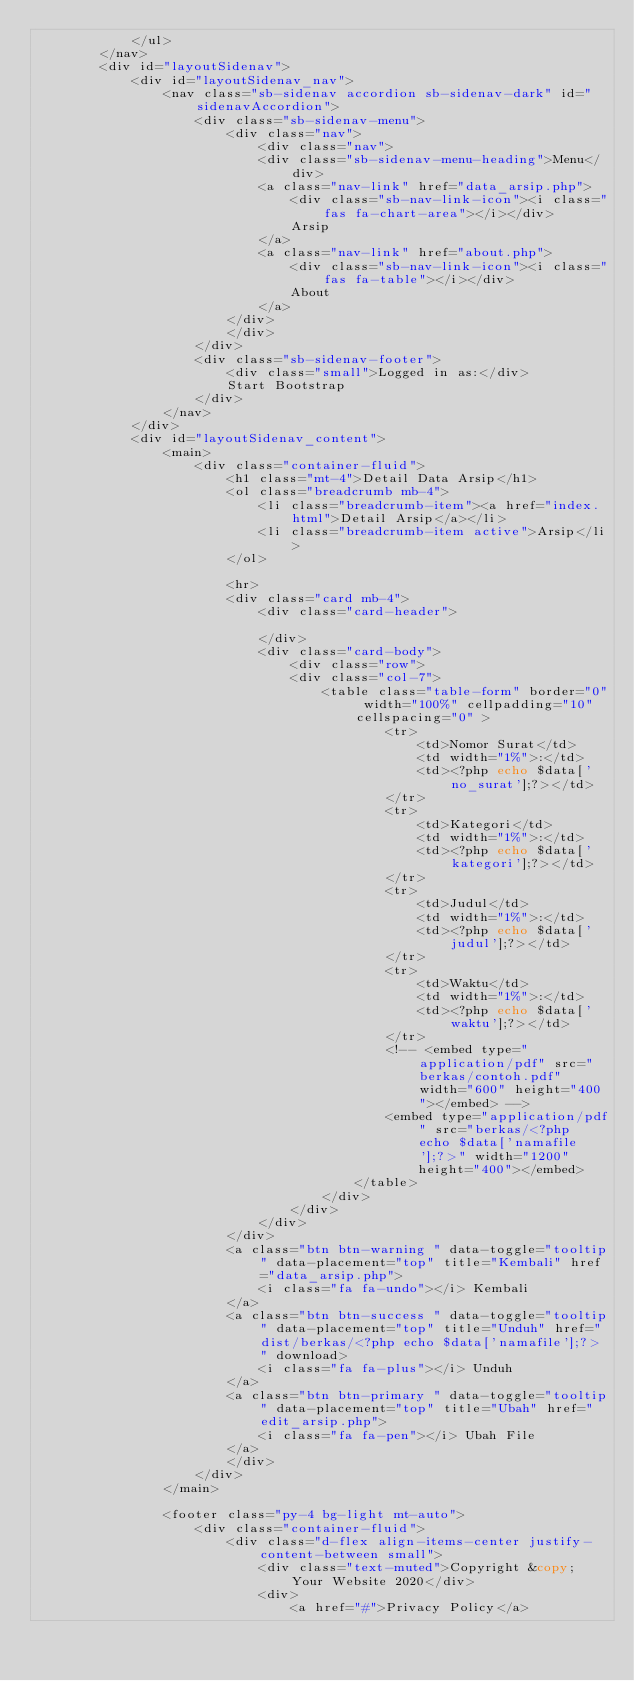Convert code to text. <code><loc_0><loc_0><loc_500><loc_500><_PHP_>            </ul>
        </nav>
        <div id="layoutSidenav">
            <div id="layoutSidenav_nav">
                <nav class="sb-sidenav accordion sb-sidenav-dark" id="sidenavAccordion">
                    <div class="sb-sidenav-menu">
                        <div class="nav">
                            <div class="nav">
                            <div class="sb-sidenav-menu-heading">Menu</div>
                            <a class="nav-link" href="data_arsip.php">
                                <div class="sb-nav-link-icon"><i class="fas fa-chart-area"></i></div>
                                Arsip
                            </a>
                            <a class="nav-link" href="about.php">
                                <div class="sb-nav-link-icon"><i class="fas fa-table"></i></div>
                                About
                            </a>
                        </div>
                        </div>
                    </div>
                    <div class="sb-sidenav-footer">
                        <div class="small">Logged in as:</div>
                        Start Bootstrap
                    </div>
                </nav>
            </div>
            <div id="layoutSidenav_content">
                <main>
                    <div class="container-fluid">
                        <h1 class="mt-4">Detail Data Arsip</h1>
                        <ol class="breadcrumb mb-4">
                            <li class="breadcrumb-item"><a href="index.html">Detail Arsip</a></li>
                            <li class="breadcrumb-item active">Arsip</li>
                        </ol>
                        
                        <hr>
                        <div class="card mb-4">
                            <div class="card-header">
                                
                            </div>
                            <div class="card-body">
                                <div class="row">
                                <div class="col-7">
                                    <table class="table-form" border="0" width="100%" cellpadding="10" cellspacing="0" >
                                            <tr>
                                                <td>Nomor Surat</td>
                                                <td width="1%">:</td>
                                                <td><?php echo $data['no_surat'];?></td>
                                            </tr>
                                            <tr>
                                                <td>Kategori</td>
                                                <td width="1%">:</td>
                                                <td><?php echo $data['kategori'];?></td>
                                            </tr>
                                            <tr>
                                                <td>Judul</td>
                                                <td width="1%">:</td>
                                                <td><?php echo $data['judul'];?></td>
                                            </tr>
                                            <tr>
                                                <td>Waktu</td>
                                                <td width="1%">:</td>
                                                <td><?php echo $data['waktu'];?></td>
                                            </tr>
                                            <!-- <embed type="application/pdf" src="berkas/contoh.pdf" width="600" height="400"></embed> -->
                                            <embed type="application/pdf" src="berkas/<?php echo $data['namafile'];?>" width="1200"
                                                height="400"></embed>
                                        </table>
                                    </div>
                                </div>
                            </div>
                        </div>
                        <a class="btn btn-warning " data-toggle="tooltip" data-placement="top" title="Kembali" href="data_arsip.php">
                            <i class="fa fa-undo"></i> Kembali
                        </a>
                        <a class="btn btn-success " data-toggle="tooltip" data-placement="top" title="Unduh" href="dist/berkas/<?php echo $data['namafile'];?>" download>
                            <i class="fa fa-plus"></i> Unduh
                        </a>
                        <a class="btn btn-primary " data-toggle="tooltip" data-placement="top" title="Ubah" href="edit_arsip.php">
                            <i class="fa fa-pen"></i> Ubah File
                        </a>
                        </div>
                    </div>
                </main>

                <footer class="py-4 bg-light mt-auto">
                    <div class="container-fluid">
                        <div class="d-flex align-items-center justify-content-between small">
                            <div class="text-muted">Copyright &copy; Your Website 2020</div>
                            <div>
                                <a href="#">Privacy Policy</a></code> 